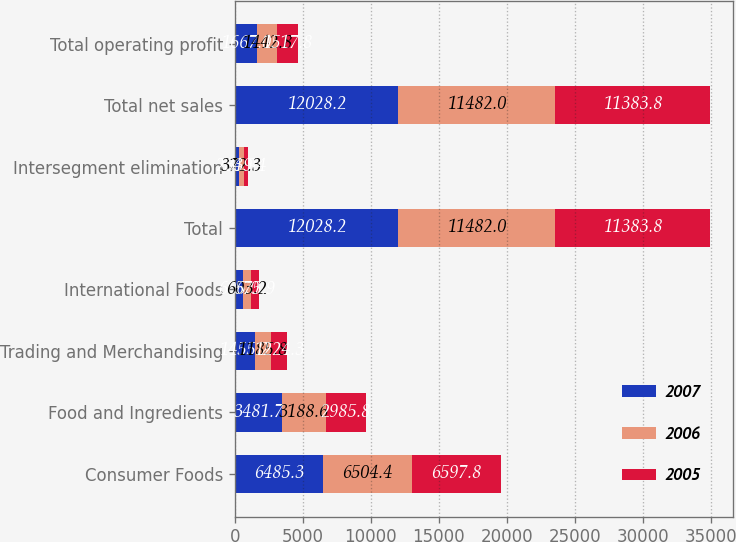Convert chart. <chart><loc_0><loc_0><loc_500><loc_500><stacked_bar_chart><ecel><fcel>Consumer Foods<fcel>Food and Ingredients<fcel>Trading and Merchandising<fcel>International Foods<fcel>Total<fcel>Intersegment elimination<fcel>Total net sales<fcel>Total operating profit<nl><fcel>2007<fcel>6485.3<fcel>3481.7<fcel>1455.2<fcel>606<fcel>12028.2<fcel>284.9<fcel>12028.2<fcel>1667<nl><fcel>2006<fcel>6504.4<fcel>3188.6<fcel>1185.8<fcel>603.2<fcel>11482<fcel>372.3<fcel>11482<fcel>1442.8<nl><fcel>2005<fcel>6597.8<fcel>2985.8<fcel>1224.3<fcel>575.9<fcel>11383.8<fcel>339.4<fcel>11383.8<fcel>1517.8<nl></chart> 